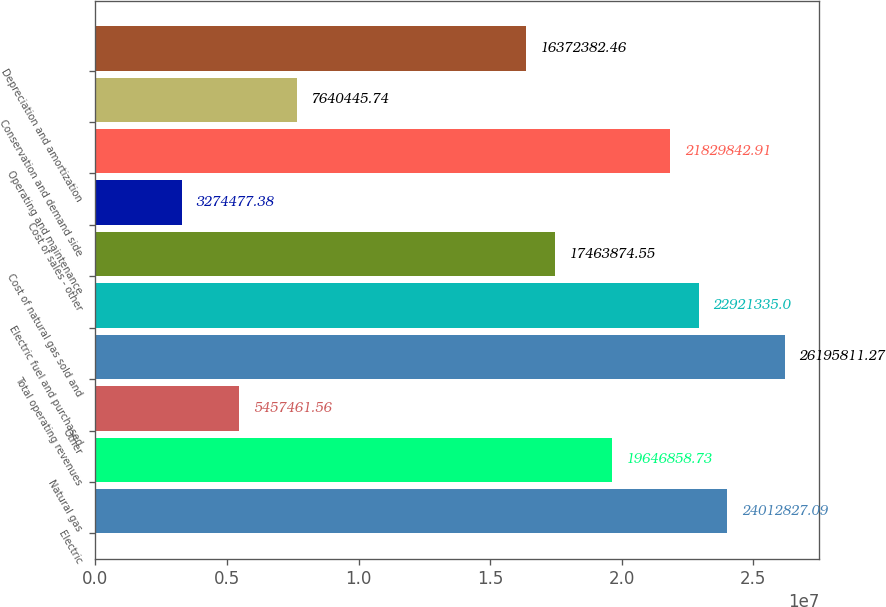Convert chart. <chart><loc_0><loc_0><loc_500><loc_500><bar_chart><fcel>Electric<fcel>Natural gas<fcel>Other<fcel>Total operating revenues<fcel>Electric fuel and purchased<fcel>Cost of natural gas sold and<fcel>Cost of sales - other<fcel>Operating and maintenance<fcel>Conservation and demand side<fcel>Depreciation and amortization<nl><fcel>2.40128e+07<fcel>1.96469e+07<fcel>5.45746e+06<fcel>2.61958e+07<fcel>2.29213e+07<fcel>1.74639e+07<fcel>3.27448e+06<fcel>2.18298e+07<fcel>7.64045e+06<fcel>1.63724e+07<nl></chart> 